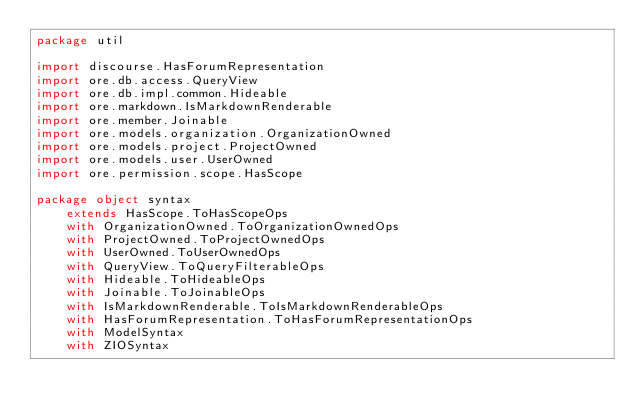<code> <loc_0><loc_0><loc_500><loc_500><_Scala_>package util

import discourse.HasForumRepresentation
import ore.db.access.QueryView
import ore.db.impl.common.Hideable
import ore.markdown.IsMarkdownRenderable
import ore.member.Joinable
import ore.models.organization.OrganizationOwned
import ore.models.project.ProjectOwned
import ore.models.user.UserOwned
import ore.permission.scope.HasScope

package object syntax
    extends HasScope.ToHasScopeOps
    with OrganizationOwned.ToOrganizationOwnedOps
    with ProjectOwned.ToProjectOwnedOps
    with UserOwned.ToUserOwnedOps
    with QueryView.ToQueryFilterableOps
    with Hideable.ToHideableOps
    with Joinable.ToJoinableOps
    with IsMarkdownRenderable.ToIsMarkdownRenderableOps
    with HasForumRepresentation.ToHasForumRepresentationOps
    with ModelSyntax
    with ZIOSyntax
</code> 